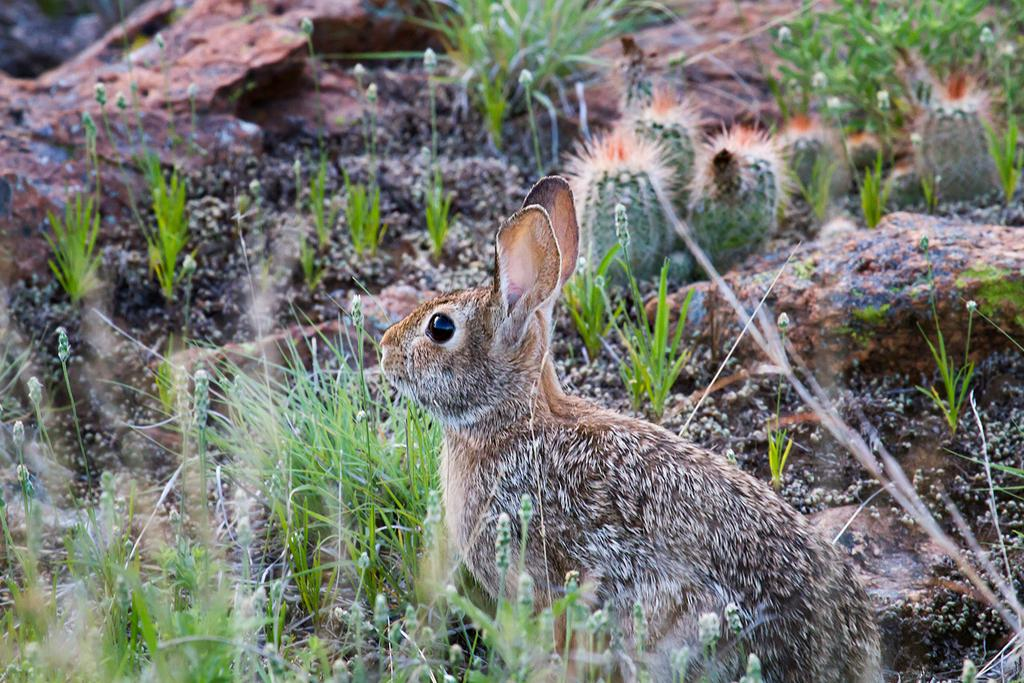What animal is present in the image? There is a rabbit in the image. Where is the rabbit located? The rabbit is on the ground. What type of vegetation is present on the ground? The ground is covered with grass and has cactus plants. What else can be found on the ground in the image? There are stones on the ground. What type of arch can be seen in the background of the image? There is no arch present in the image; it features a rabbit on the ground with grass, cactus plants, and stones. 